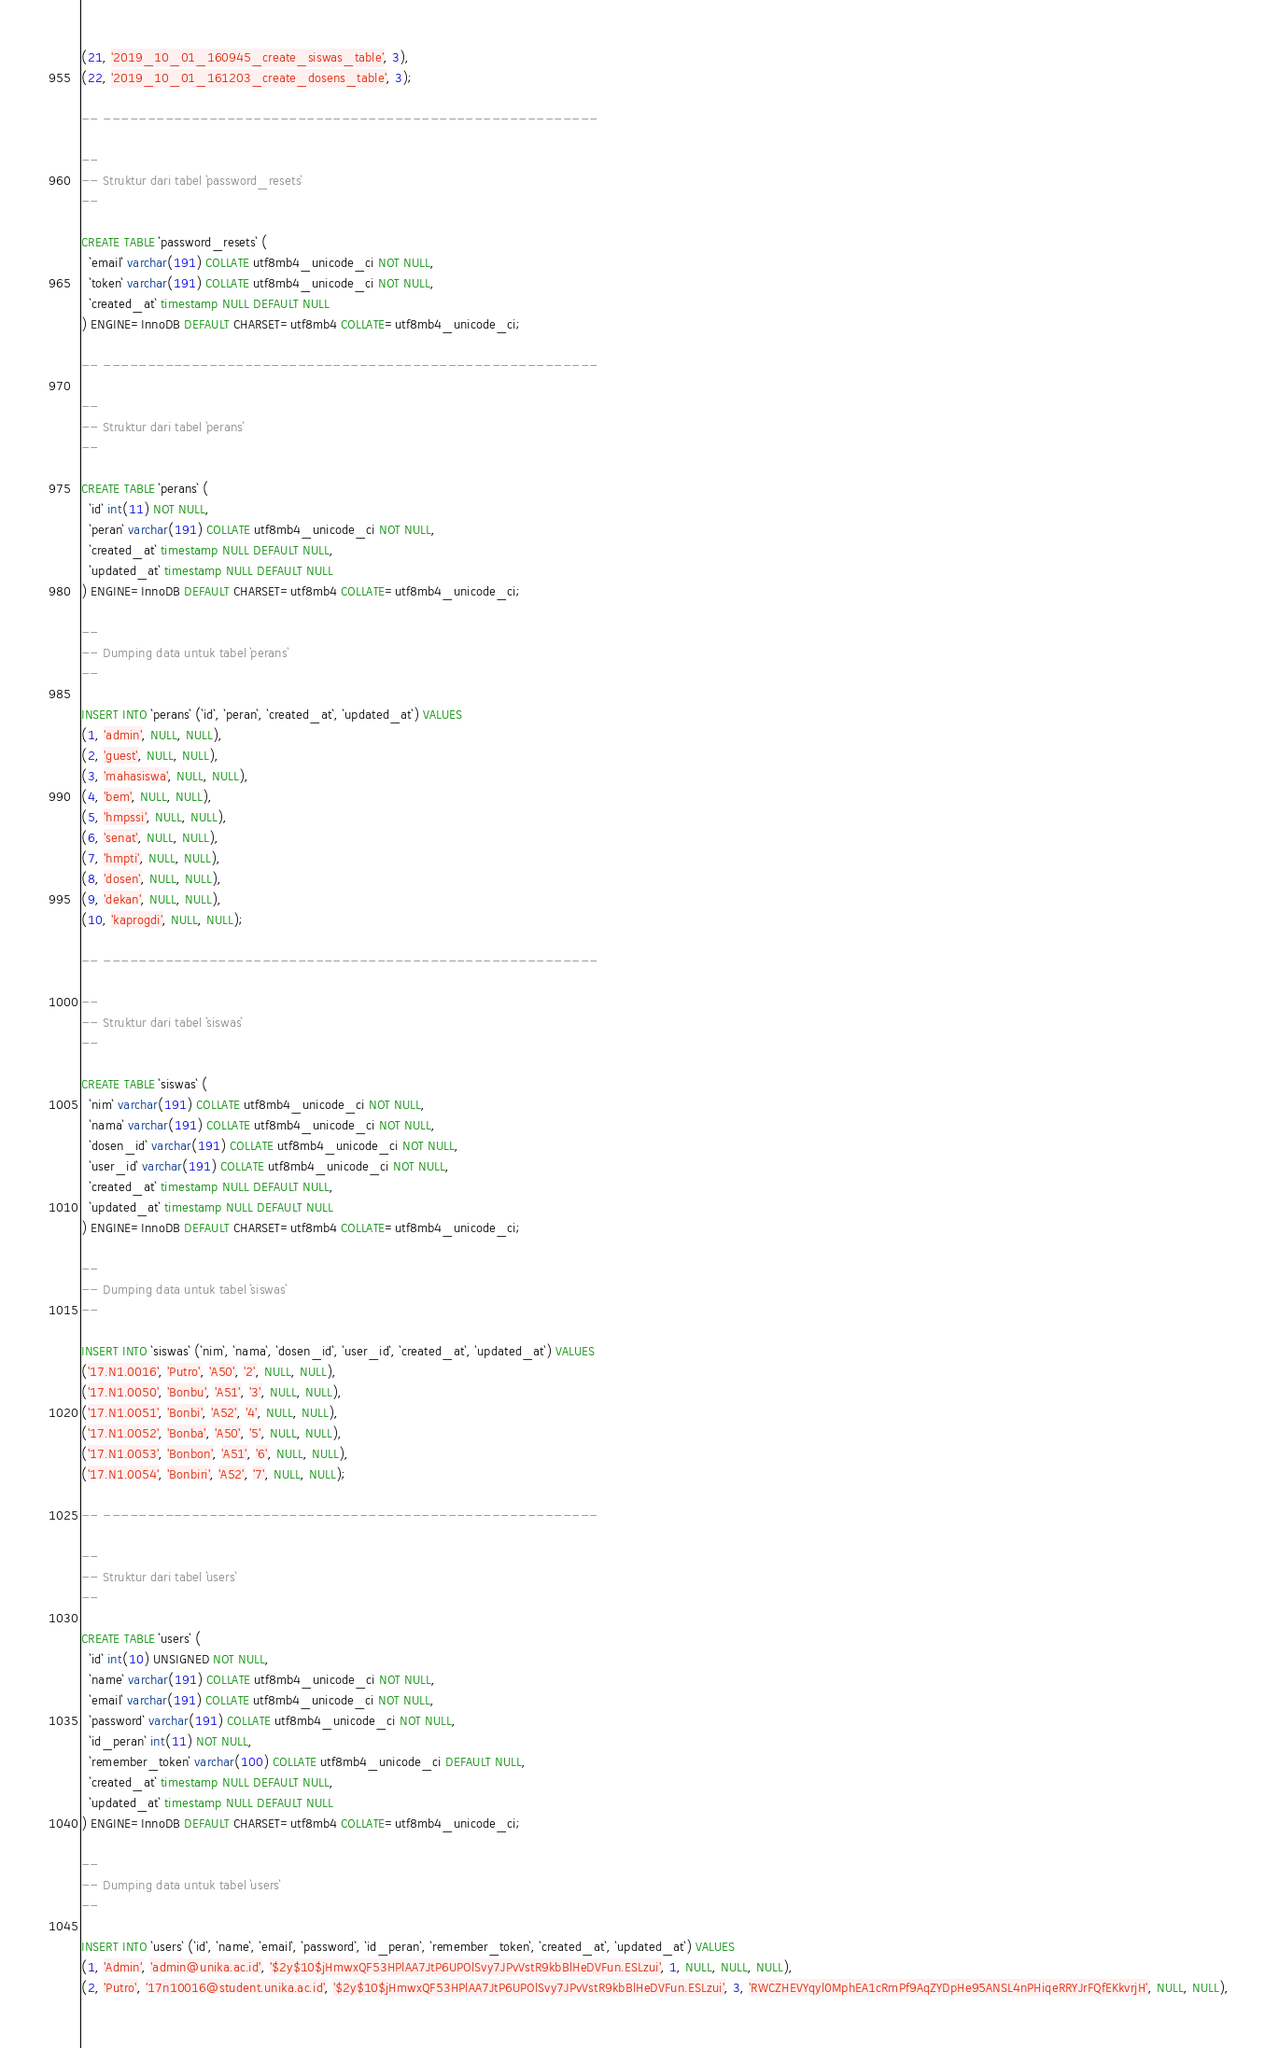<code> <loc_0><loc_0><loc_500><loc_500><_SQL_>(21, '2019_10_01_160945_create_siswas_table', 3),
(22, '2019_10_01_161203_create_dosens_table', 3);

-- --------------------------------------------------------

--
-- Struktur dari tabel `password_resets`
--

CREATE TABLE `password_resets` (
  `email` varchar(191) COLLATE utf8mb4_unicode_ci NOT NULL,
  `token` varchar(191) COLLATE utf8mb4_unicode_ci NOT NULL,
  `created_at` timestamp NULL DEFAULT NULL
) ENGINE=InnoDB DEFAULT CHARSET=utf8mb4 COLLATE=utf8mb4_unicode_ci;

-- --------------------------------------------------------

--
-- Struktur dari tabel `perans`
--

CREATE TABLE `perans` (
  `id` int(11) NOT NULL,
  `peran` varchar(191) COLLATE utf8mb4_unicode_ci NOT NULL,
  `created_at` timestamp NULL DEFAULT NULL,
  `updated_at` timestamp NULL DEFAULT NULL
) ENGINE=InnoDB DEFAULT CHARSET=utf8mb4 COLLATE=utf8mb4_unicode_ci;

--
-- Dumping data untuk tabel `perans`
--

INSERT INTO `perans` (`id`, `peran`, `created_at`, `updated_at`) VALUES
(1, 'admin', NULL, NULL),
(2, 'guest', NULL, NULL),
(3, 'mahasiswa', NULL, NULL),
(4, 'bem', NULL, NULL),
(5, 'hmpssi', NULL, NULL),
(6, 'senat', NULL, NULL),
(7, 'hmpti', NULL, NULL),
(8, 'dosen', NULL, NULL),
(9, 'dekan', NULL, NULL),
(10, 'kaprogdi', NULL, NULL);

-- --------------------------------------------------------

--
-- Struktur dari tabel `siswas`
--

CREATE TABLE `siswas` (
  `nim` varchar(191) COLLATE utf8mb4_unicode_ci NOT NULL,
  `nama` varchar(191) COLLATE utf8mb4_unicode_ci NOT NULL,
  `dosen_id` varchar(191) COLLATE utf8mb4_unicode_ci NOT NULL,
  `user_id` varchar(191) COLLATE utf8mb4_unicode_ci NOT NULL,
  `created_at` timestamp NULL DEFAULT NULL,
  `updated_at` timestamp NULL DEFAULT NULL
) ENGINE=InnoDB DEFAULT CHARSET=utf8mb4 COLLATE=utf8mb4_unicode_ci;

--
-- Dumping data untuk tabel `siswas`
--

INSERT INTO `siswas` (`nim`, `nama`, `dosen_id`, `user_id`, `created_at`, `updated_at`) VALUES
('17.N1.0016', 'Putro', 'A50', '2', NULL, NULL),
('17.N1.0050', 'Bonbu', 'A51', '3', NULL, NULL),
('17.N1.0051', 'Bonbi', 'A52', '4', NULL, NULL),
('17.N1.0052', 'Bonba', 'A50', '5', NULL, NULL),
('17.N1.0053', 'Bonbon', 'A51', '6', NULL, NULL),
('17.N1.0054', 'Bonbiri', 'A52', '7', NULL, NULL);

-- --------------------------------------------------------

--
-- Struktur dari tabel `users`
--

CREATE TABLE `users` (
  `id` int(10) UNSIGNED NOT NULL,
  `name` varchar(191) COLLATE utf8mb4_unicode_ci NOT NULL,
  `email` varchar(191) COLLATE utf8mb4_unicode_ci NOT NULL,
  `password` varchar(191) COLLATE utf8mb4_unicode_ci NOT NULL,
  `id_peran` int(11) NOT NULL,
  `remember_token` varchar(100) COLLATE utf8mb4_unicode_ci DEFAULT NULL,
  `created_at` timestamp NULL DEFAULT NULL,
  `updated_at` timestamp NULL DEFAULT NULL
) ENGINE=InnoDB DEFAULT CHARSET=utf8mb4 COLLATE=utf8mb4_unicode_ci;

--
-- Dumping data untuk tabel `users`
--

INSERT INTO `users` (`id`, `name`, `email`, `password`, `id_peran`, `remember_token`, `created_at`, `updated_at`) VALUES
(1, 'Admin', 'admin@unika.ac.id', '$2y$10$jHmwxQF53HPlAA7JtP6UPOlSvy7JPvVstR9kbBlHeDVFun.ESLzui', 1, NULL, NULL, NULL),
(2, 'Putro', '17n10016@student.unika.ac.id', '$2y$10$jHmwxQF53HPlAA7JtP6UPOlSvy7JPvVstR9kbBlHeDVFun.ESLzui', 3, 'RWCZHEVYqyl0MphEA1cRmPf9AqZYDpHe95ANSL4nPHiqeRRYJrFQfEKkvrjH', NULL, NULL),</code> 